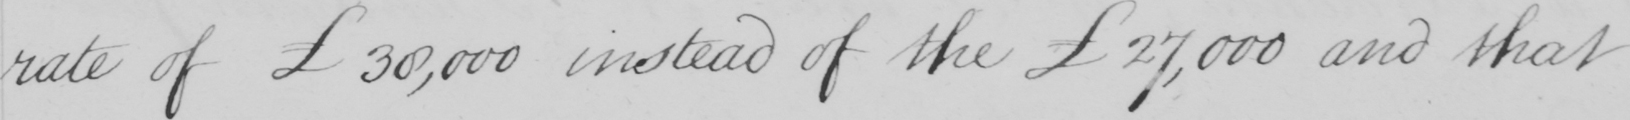Can you tell me what this handwritten text says? rate of £30,000 instead of the £27,000 and that 